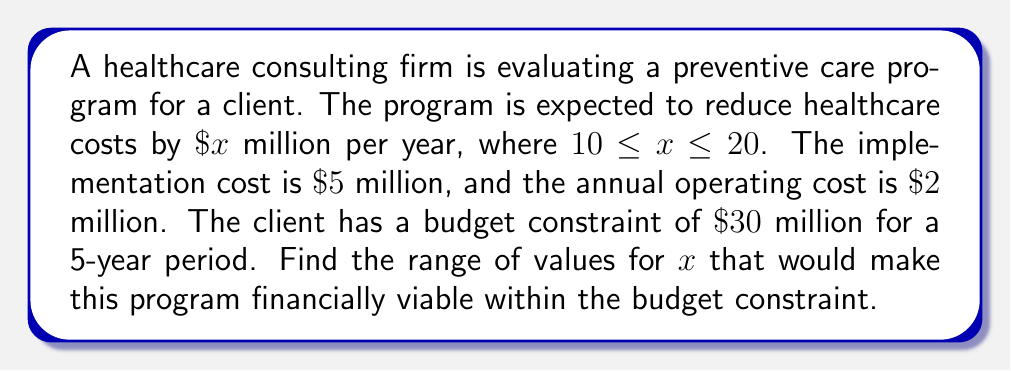Help me with this question. Let's approach this step-by-step:

1) First, let's set up an inequality to represent the budget constraint over 5 years:

   Implementation cost + (Annual operating cost × 5 years) ≤ Budget
   $5 + (2 \times 5) \leq 30$

2) Now, let's include the cost savings over 5 years:

   $5 + (2 \times 5) - (x \times 5) \leq 30$

3) Simplify:

   $5 + 10 - 5x \leq 30$
   $15 - 5x \leq 30$

4) Subtract 15 from both sides:

   $-5x \leq 15$

5) Divide both sides by -5 (remember to flip the inequality sign when dividing by a negative number):

   $x \geq 3$

6) So, for the program to be within budget, $x$ must be at least 3. However, we're given that $x$ is between 10 and 20. Therefore, the lower bound of 3 is superseded by the given lower bound of 10.

7) The upper bound remains 20, as given in the original constraints.

Therefore, the range of values for $x$ that make the program financially viable within the budget constraint is $10 \leq x \leq 20$.
Answer: $10 \leq x \leq 20$ 